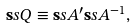<formula> <loc_0><loc_0><loc_500><loc_500>\mathbf s s { Q } \equiv \mathbf s s { A } ^ { \prime } \mathbf s s { A } ^ { - 1 } ,</formula> 